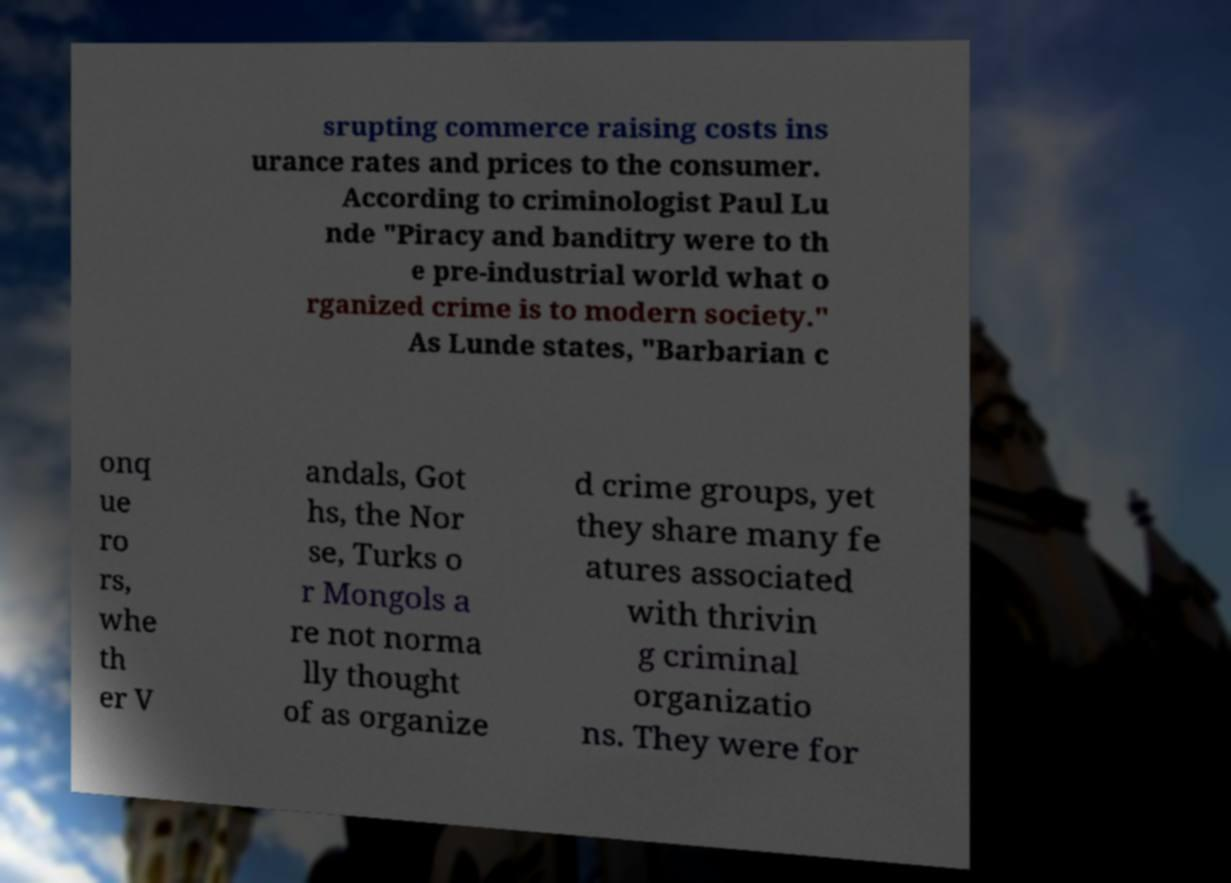Please read and relay the text visible in this image. What does it say? srupting commerce raising costs ins urance rates and prices to the consumer. According to criminologist Paul Lu nde "Piracy and banditry were to th e pre-industrial world what o rganized crime is to modern society." As Lunde states, "Barbarian c onq ue ro rs, whe th er V andals, Got hs, the Nor se, Turks o r Mongols a re not norma lly thought of as organize d crime groups, yet they share many fe atures associated with thrivin g criminal organizatio ns. They were for 